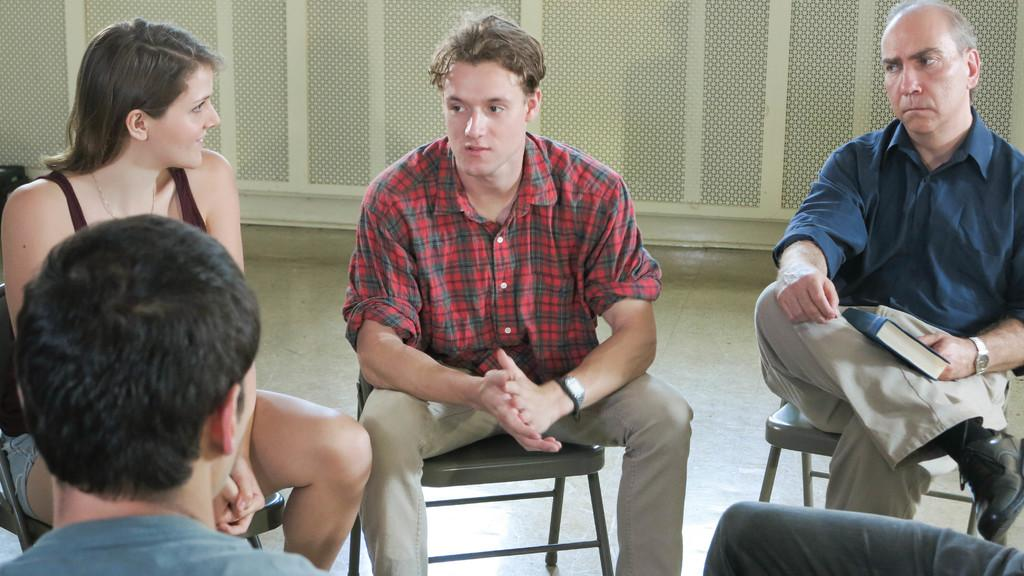Where was the image taken? The image was taken inside a room. What are the people in the image doing? There is a group of people sitting on chairs in the image. What color is the wall visible in the background of the image? The wall in the background of the image is white. What mathematical operation is being performed by the people in the image? There is no indication in the image that the people are performing any mathematical operations. 